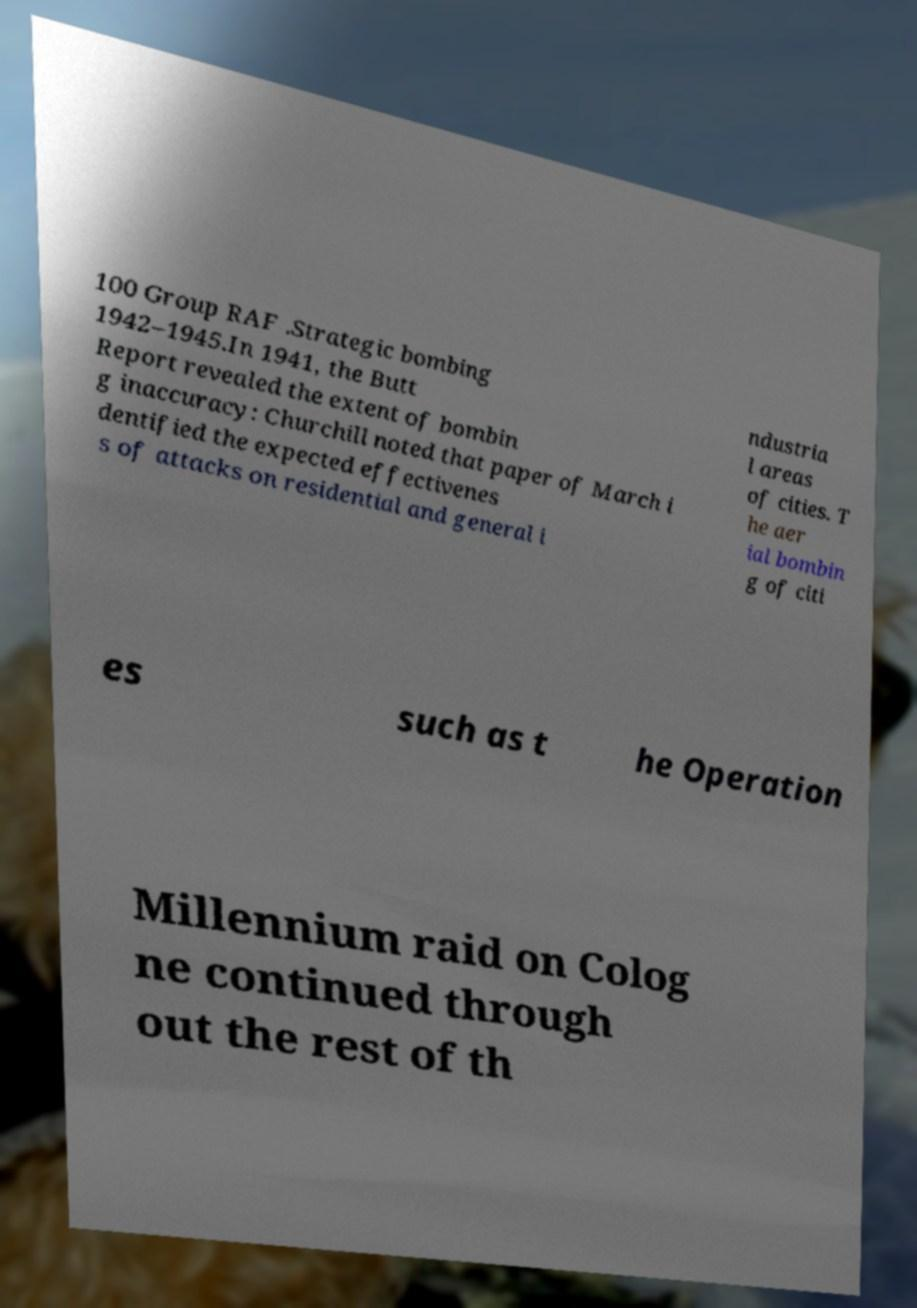Please identify and transcribe the text found in this image. 100 Group RAF .Strategic bombing 1942–1945.In 1941, the Butt Report revealed the extent of bombin g inaccuracy: Churchill noted that paper of March i dentified the expected effectivenes s of attacks on residential and general i ndustria l areas of cities. T he aer ial bombin g of citi es such as t he Operation Millennium raid on Colog ne continued through out the rest of th 